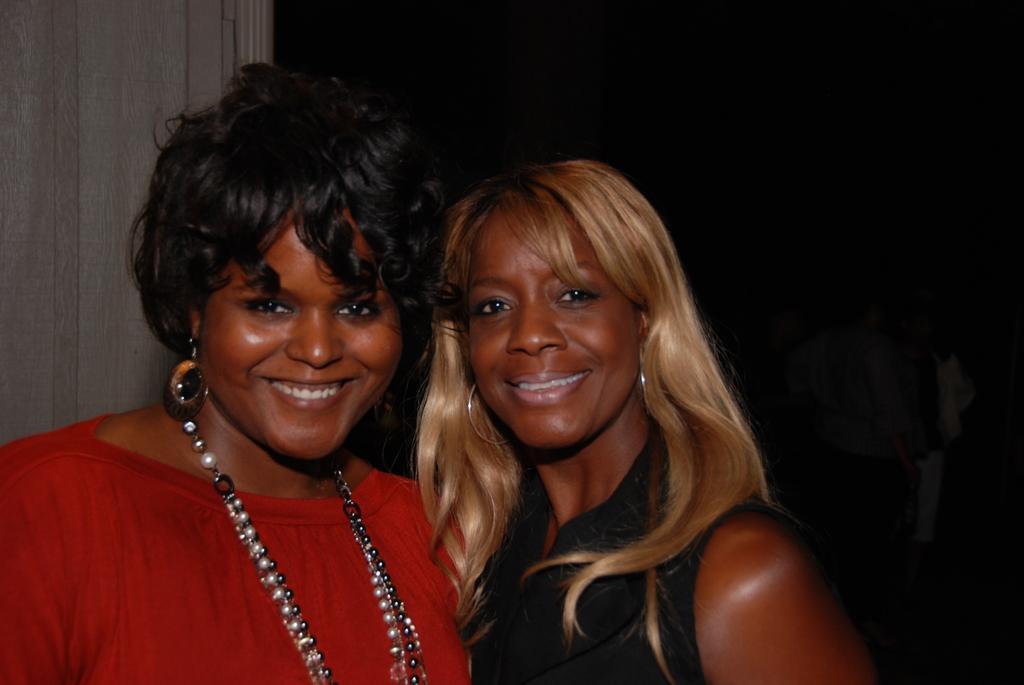Describe this image in one or two sentences. In this picture I can see two persons smiling, and there are persons in the dark background. 